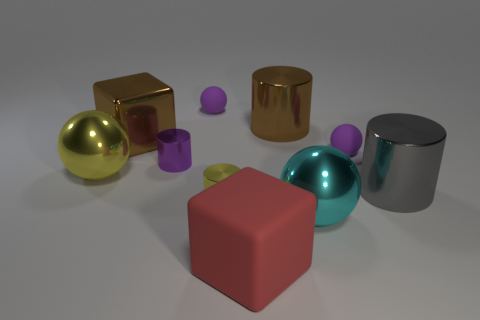Subtract all tiny purple cylinders. How many cylinders are left? 3 Subtract all yellow cylinders. How many cylinders are left? 3 Subtract all cylinders. How many objects are left? 6 Subtract 2 cylinders. How many cylinders are left? 2 Subtract 0 red balls. How many objects are left? 10 Subtract all cyan balls. Subtract all yellow cubes. How many balls are left? 3 Subtract all brown blocks. How many red cylinders are left? 0 Subtract all large yellow objects. Subtract all tiny shiny things. How many objects are left? 7 Add 6 red cubes. How many red cubes are left? 7 Add 6 tiny yellow shiny balls. How many tiny yellow shiny balls exist? 6 